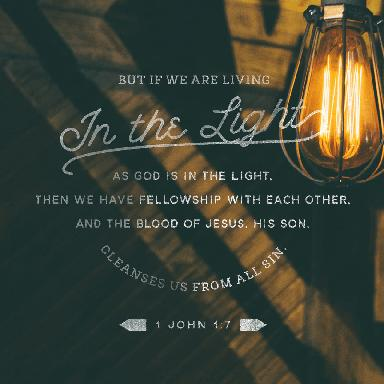What does the imagery around the text in this picture symbolize? The use of the light bulb in the image, shining brightly in a dim environment, visually symbolizes the metaphor of 'living in the light' mentioned in 1 John 1:7. This evokes the idea of God's truth dispelling the darkness of sin, much as light scatters shadows, and represents spiritual enlightenment and purity. How does the imagery enhance the message of the verse? The imagery enhances the verse by providing a tangible representation of the abstract concepts it discusses. The contrast between light and dark immediately conveys the struggle between good and evil, purity and sin. By juxtaposing the powerful light against a murky background, the image underscores the verse’s message about the stark difference between living within God's light versus outside of it. 